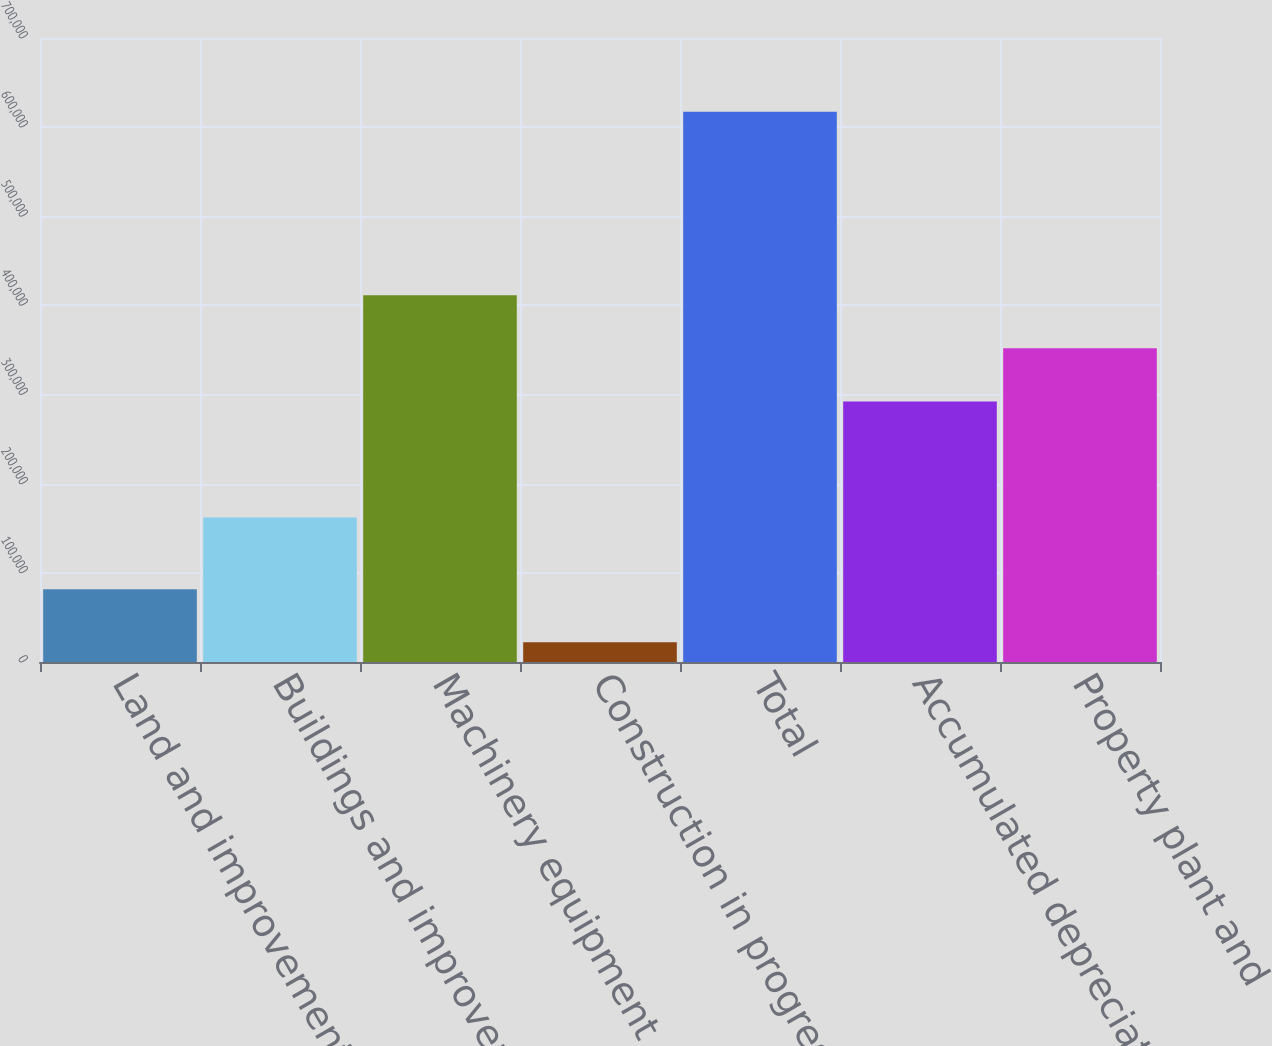Convert chart to OTSL. <chart><loc_0><loc_0><loc_500><loc_500><bar_chart><fcel>Land and improvements<fcel>Buildings and improvements<fcel>Machinery equipment and other<fcel>Construction in progress<fcel>Total<fcel>Accumulated depreciation<fcel>Property plant and<nl><fcel>81557.3<fcel>161990<fcel>411357<fcel>22037<fcel>617240<fcel>292316<fcel>351836<nl></chart> 